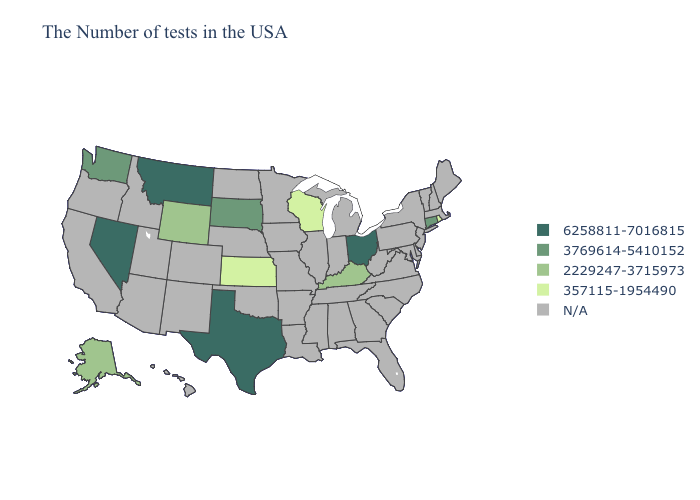Which states have the highest value in the USA?
Quick response, please. Ohio, Texas, Montana, Nevada. What is the highest value in the West ?
Quick response, please. 6258811-7016815. Does Wyoming have the lowest value in the USA?
Be succinct. No. Name the states that have a value in the range 6258811-7016815?
Write a very short answer. Ohio, Texas, Montana, Nevada. Name the states that have a value in the range 3769614-5410152?
Write a very short answer. Connecticut, South Dakota, Washington. Name the states that have a value in the range 3769614-5410152?
Quick response, please. Connecticut, South Dakota, Washington. Does the first symbol in the legend represent the smallest category?
Be succinct. No. Name the states that have a value in the range N/A?
Give a very brief answer. Maine, Massachusetts, New Hampshire, Vermont, New York, New Jersey, Delaware, Maryland, Pennsylvania, Virginia, North Carolina, South Carolina, West Virginia, Florida, Georgia, Michigan, Indiana, Alabama, Tennessee, Illinois, Mississippi, Louisiana, Missouri, Arkansas, Minnesota, Iowa, Nebraska, Oklahoma, North Dakota, Colorado, New Mexico, Utah, Arizona, Idaho, California, Oregon, Hawaii. Which states have the lowest value in the USA?
Concise answer only. Rhode Island, Wisconsin, Kansas. Among the states that border New Mexico , which have the lowest value?
Keep it brief. Texas. Which states have the lowest value in the USA?
Be succinct. Rhode Island, Wisconsin, Kansas. What is the lowest value in states that border Ohio?
Keep it brief. 2229247-3715973. Which states have the lowest value in the USA?
Be succinct. Rhode Island, Wisconsin, Kansas. 